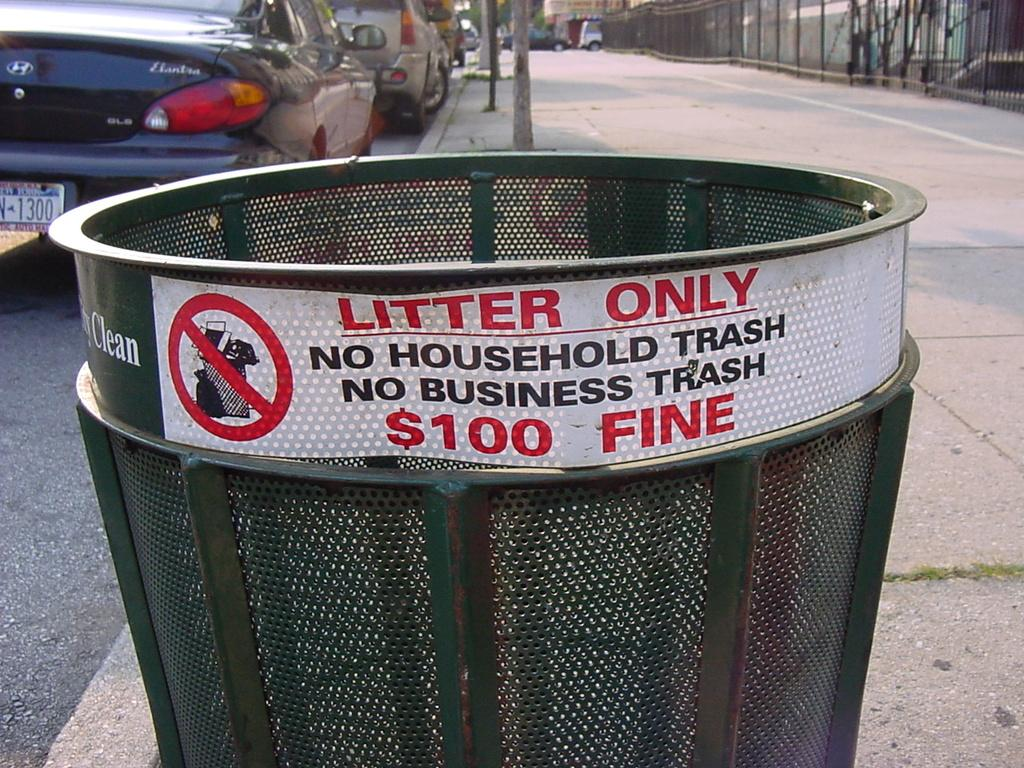<image>
Summarize the visual content of the image. A wire trash bin that says no household trash as well as no business trash. 